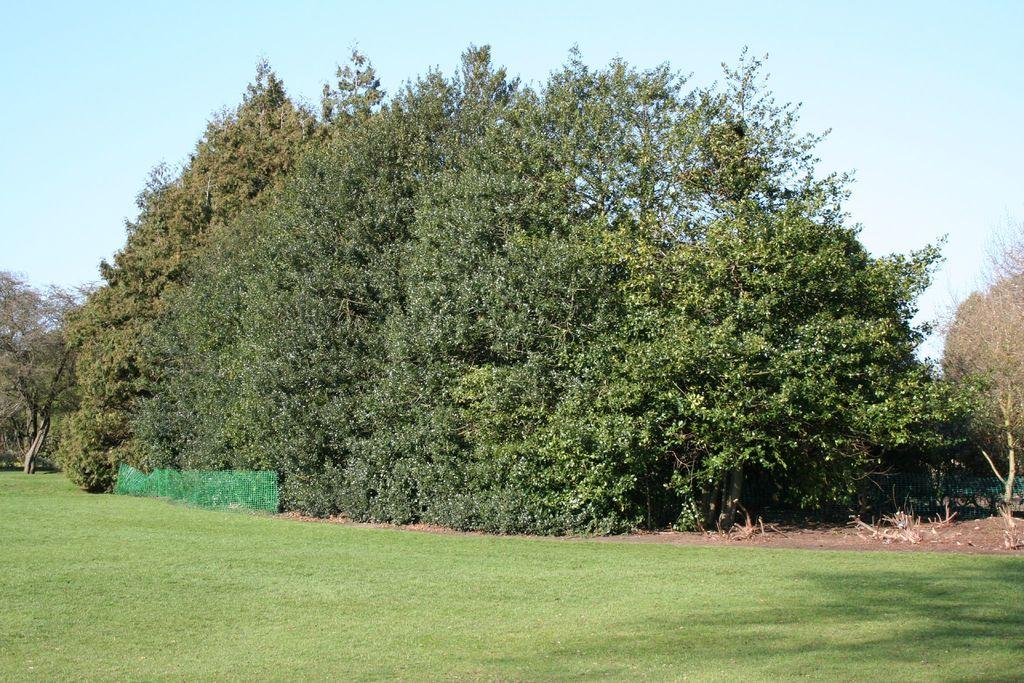Where was the image taken? The image was taken in a garden. What type of vegetation can be seen at the bottom of the image? There is green grass at the bottom of the image. What can be seen in the background of the image? There are many trees in the background of the image. What is visible at the top of the image? The sky is visible at the top of the image. What type of canvas is used to create the design in the image? There is no canvas or design present in the image; it is a photograph taken in a garden. 